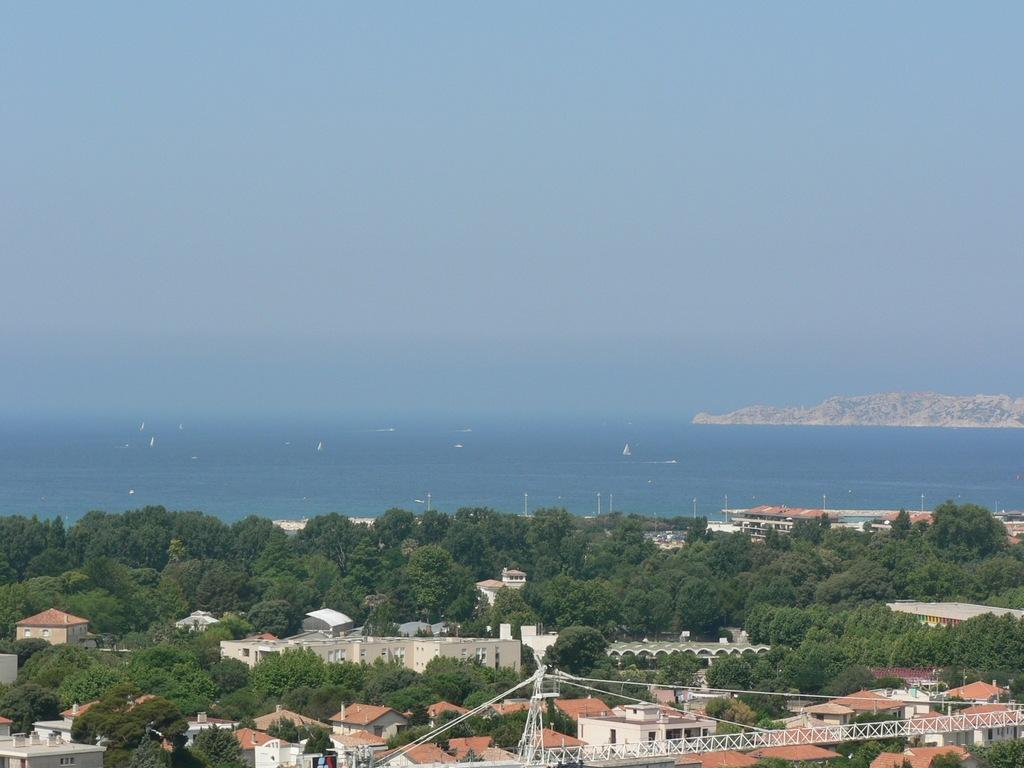What type of structures can be seen in the image? There are buildings and towers in the image. What other natural elements are present in the image? There are trees and water visible in the image. Where is the hill located in the image? The hill is on the right side of the image. What can be seen in the background of the image? The sky is visible in the background of the image. Can you describe the muscle strength of the elbow in the image? There is no mention of muscles or elbows in the image; it features buildings, towers, trees, water, a hill, and the sky. 